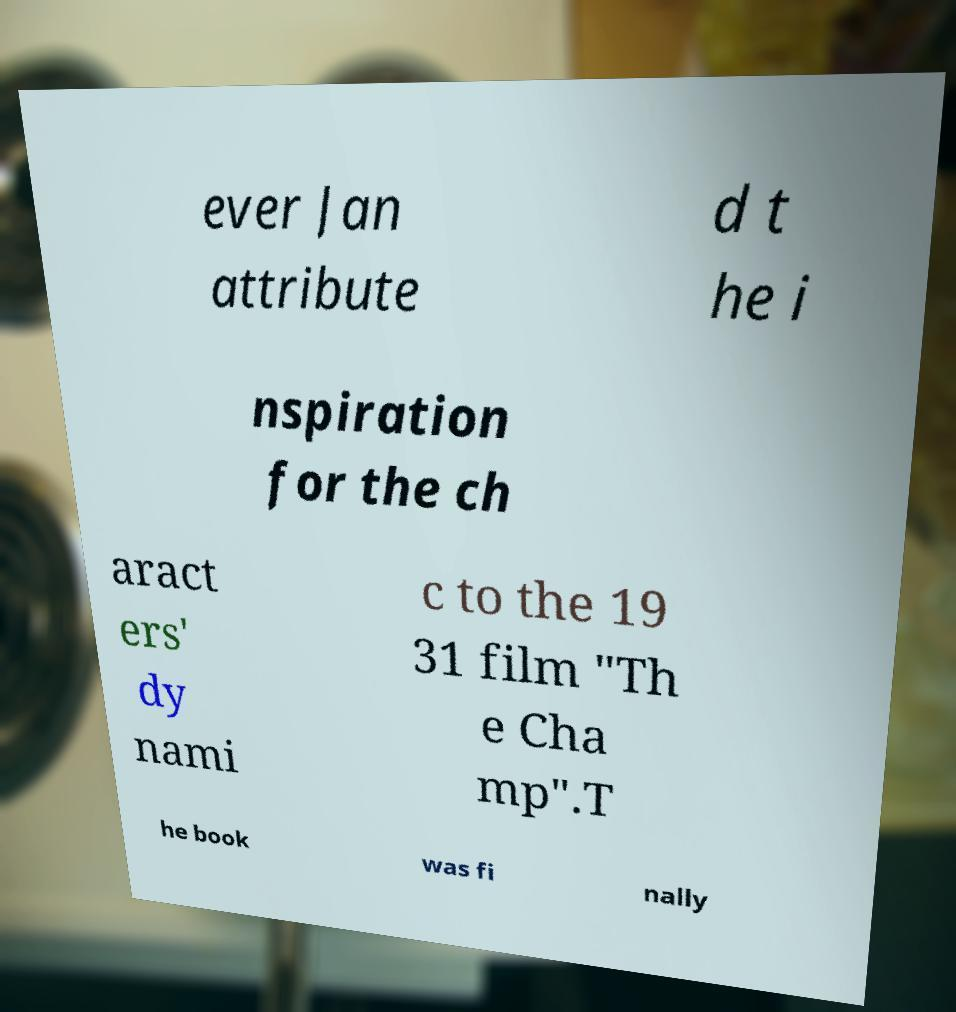For documentation purposes, I need the text within this image transcribed. Could you provide that? ever Jan attribute d t he i nspiration for the ch aract ers' dy nami c to the 19 31 film "Th e Cha mp".T he book was fi nally 